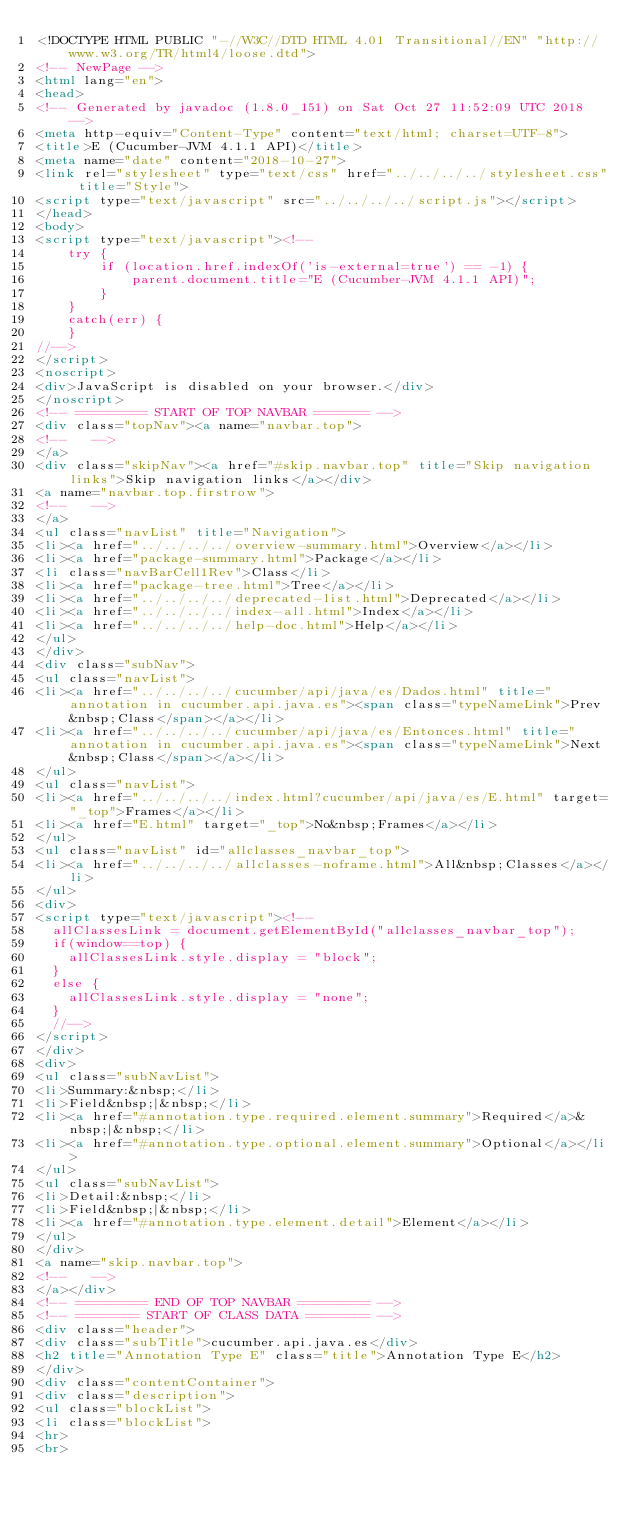Convert code to text. <code><loc_0><loc_0><loc_500><loc_500><_HTML_><!DOCTYPE HTML PUBLIC "-//W3C//DTD HTML 4.01 Transitional//EN" "http://www.w3.org/TR/html4/loose.dtd">
<!-- NewPage -->
<html lang="en">
<head>
<!-- Generated by javadoc (1.8.0_151) on Sat Oct 27 11:52:09 UTC 2018 -->
<meta http-equiv="Content-Type" content="text/html; charset=UTF-8">
<title>E (Cucumber-JVM 4.1.1 API)</title>
<meta name="date" content="2018-10-27">
<link rel="stylesheet" type="text/css" href="../../../../stylesheet.css" title="Style">
<script type="text/javascript" src="../../../../script.js"></script>
</head>
<body>
<script type="text/javascript"><!--
    try {
        if (location.href.indexOf('is-external=true') == -1) {
            parent.document.title="E (Cucumber-JVM 4.1.1 API)";
        }
    }
    catch(err) {
    }
//-->
</script>
<noscript>
<div>JavaScript is disabled on your browser.</div>
</noscript>
<!-- ========= START OF TOP NAVBAR ======= -->
<div class="topNav"><a name="navbar.top">
<!--   -->
</a>
<div class="skipNav"><a href="#skip.navbar.top" title="Skip navigation links">Skip navigation links</a></div>
<a name="navbar.top.firstrow">
<!--   -->
</a>
<ul class="navList" title="Navigation">
<li><a href="../../../../overview-summary.html">Overview</a></li>
<li><a href="package-summary.html">Package</a></li>
<li class="navBarCell1Rev">Class</li>
<li><a href="package-tree.html">Tree</a></li>
<li><a href="../../../../deprecated-list.html">Deprecated</a></li>
<li><a href="../../../../index-all.html">Index</a></li>
<li><a href="../../../../help-doc.html">Help</a></li>
</ul>
</div>
<div class="subNav">
<ul class="navList">
<li><a href="../../../../cucumber/api/java/es/Dados.html" title="annotation in cucumber.api.java.es"><span class="typeNameLink">Prev&nbsp;Class</span></a></li>
<li><a href="../../../../cucumber/api/java/es/Entonces.html" title="annotation in cucumber.api.java.es"><span class="typeNameLink">Next&nbsp;Class</span></a></li>
</ul>
<ul class="navList">
<li><a href="../../../../index.html?cucumber/api/java/es/E.html" target="_top">Frames</a></li>
<li><a href="E.html" target="_top">No&nbsp;Frames</a></li>
</ul>
<ul class="navList" id="allclasses_navbar_top">
<li><a href="../../../../allclasses-noframe.html">All&nbsp;Classes</a></li>
</ul>
<div>
<script type="text/javascript"><!--
  allClassesLink = document.getElementById("allclasses_navbar_top");
  if(window==top) {
    allClassesLink.style.display = "block";
  }
  else {
    allClassesLink.style.display = "none";
  }
  //-->
</script>
</div>
<div>
<ul class="subNavList">
<li>Summary:&nbsp;</li>
<li>Field&nbsp;|&nbsp;</li>
<li><a href="#annotation.type.required.element.summary">Required</a>&nbsp;|&nbsp;</li>
<li><a href="#annotation.type.optional.element.summary">Optional</a></li>
</ul>
<ul class="subNavList">
<li>Detail:&nbsp;</li>
<li>Field&nbsp;|&nbsp;</li>
<li><a href="#annotation.type.element.detail">Element</a></li>
</ul>
</div>
<a name="skip.navbar.top">
<!--   -->
</a></div>
<!-- ========= END OF TOP NAVBAR ========= -->
<!-- ======== START OF CLASS DATA ======== -->
<div class="header">
<div class="subTitle">cucumber.api.java.es</div>
<h2 title="Annotation Type E" class="title">Annotation Type E</h2>
</div>
<div class="contentContainer">
<div class="description">
<ul class="blockList">
<li class="blockList">
<hr>
<br></code> 